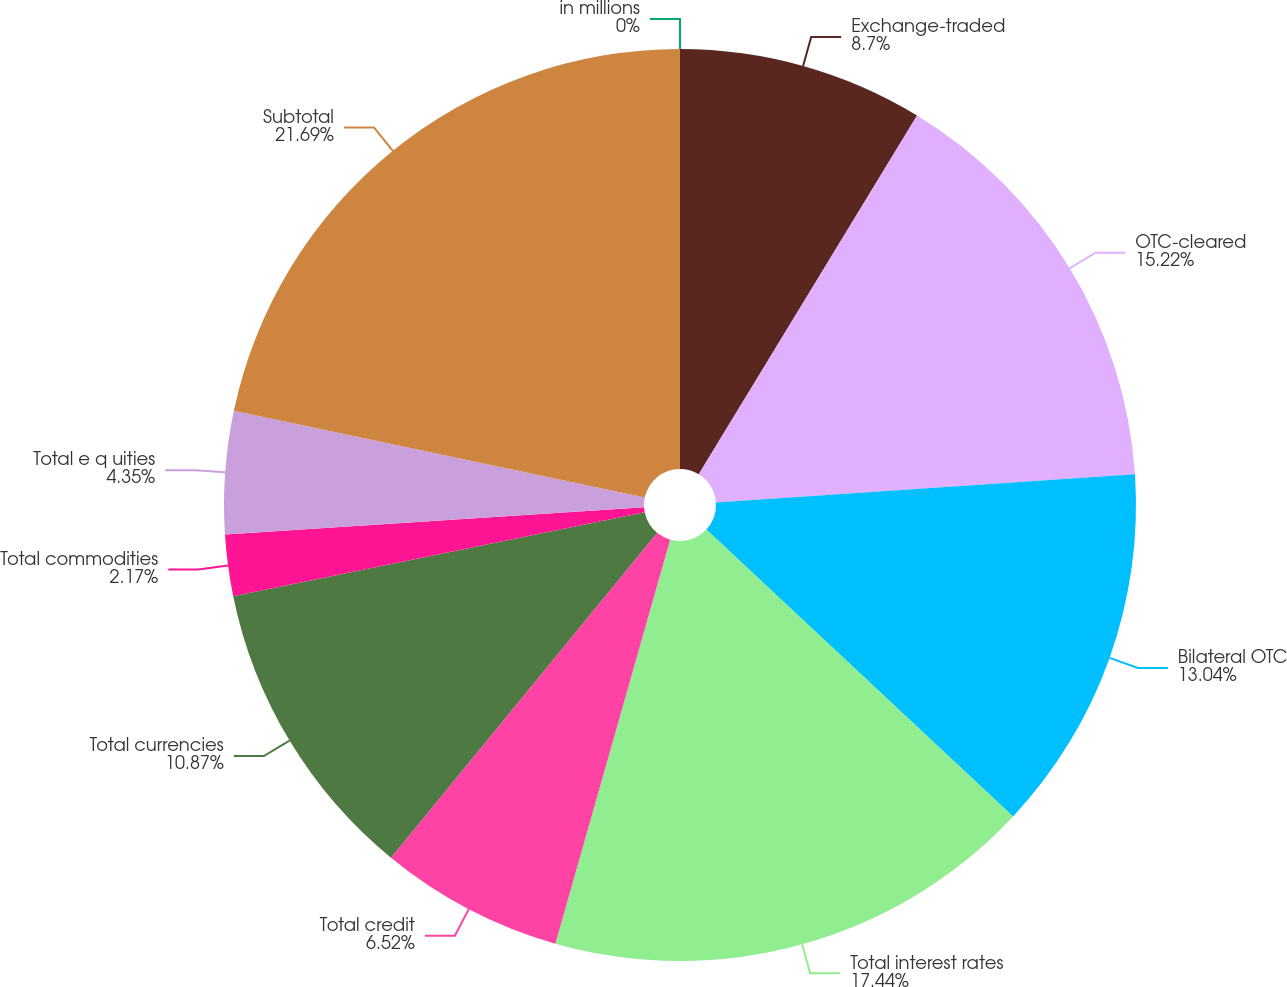Convert chart to OTSL. <chart><loc_0><loc_0><loc_500><loc_500><pie_chart><fcel>in millions<fcel>Exchange-traded<fcel>OTC-cleared<fcel>Bilateral OTC<fcel>Total interest rates<fcel>Total credit<fcel>Total currencies<fcel>Total commodities<fcel>Total e q uities<fcel>Subtotal<nl><fcel>0.0%<fcel>8.7%<fcel>15.22%<fcel>13.04%<fcel>17.44%<fcel>6.52%<fcel>10.87%<fcel>2.17%<fcel>4.35%<fcel>21.68%<nl></chart> 